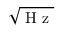Convert formula to latex. <formula><loc_0><loc_0><loc_500><loc_500>\sqrt { H z }</formula> 